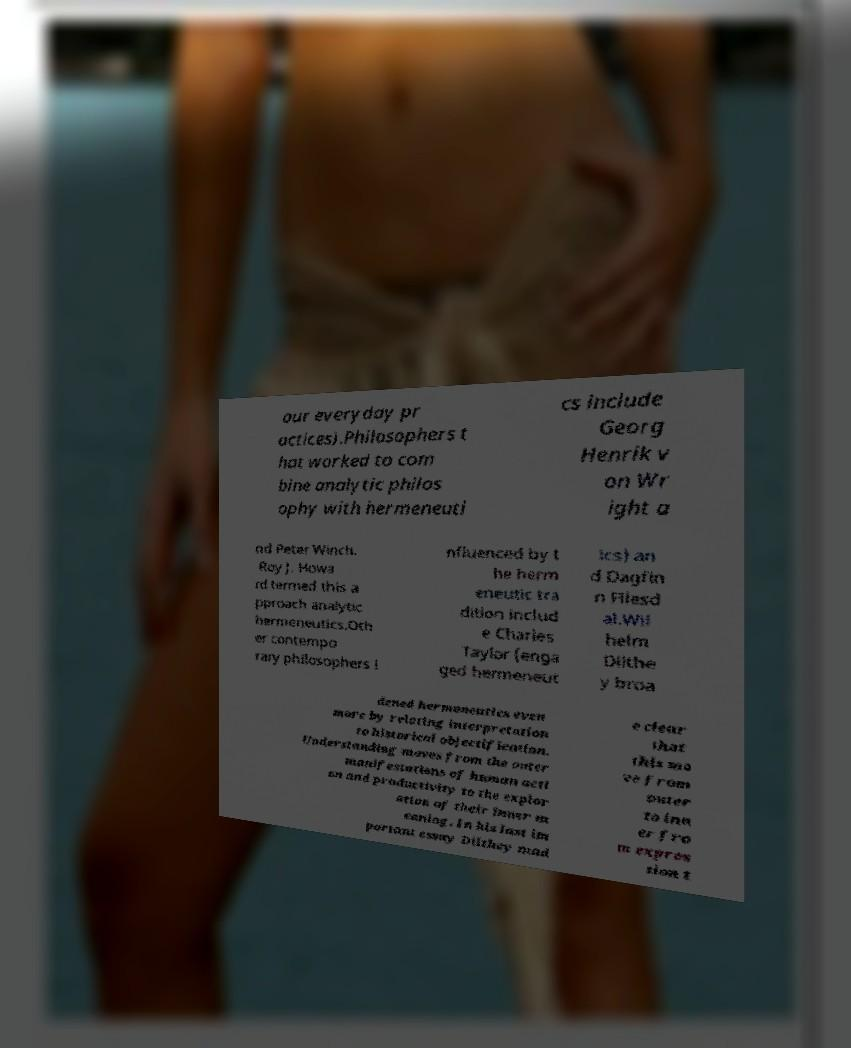Could you assist in decoding the text presented in this image and type it out clearly? our everyday pr actices).Philosophers t hat worked to com bine analytic philos ophy with hermeneuti cs include Georg Henrik v on Wr ight a nd Peter Winch. Roy J. Howa rd termed this a pproach analytic hermeneutics.Oth er contempo rary philosophers i nfluenced by t he herm eneutic tra dition includ e Charles Taylor (enga ged hermeneut ics) an d Dagfin n Fllesd al.Wil helm Dilthe y broa dened hermeneutics even more by relating interpretation to historical objectification. Understanding moves from the outer manifestations of human acti on and productivity to the explor ation of their inner m eaning. In his last im portant essay Dilthey mad e clear that this mo ve from outer to inn er fro m expres sion t 